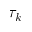<formula> <loc_0><loc_0><loc_500><loc_500>\tau _ { k }</formula> 